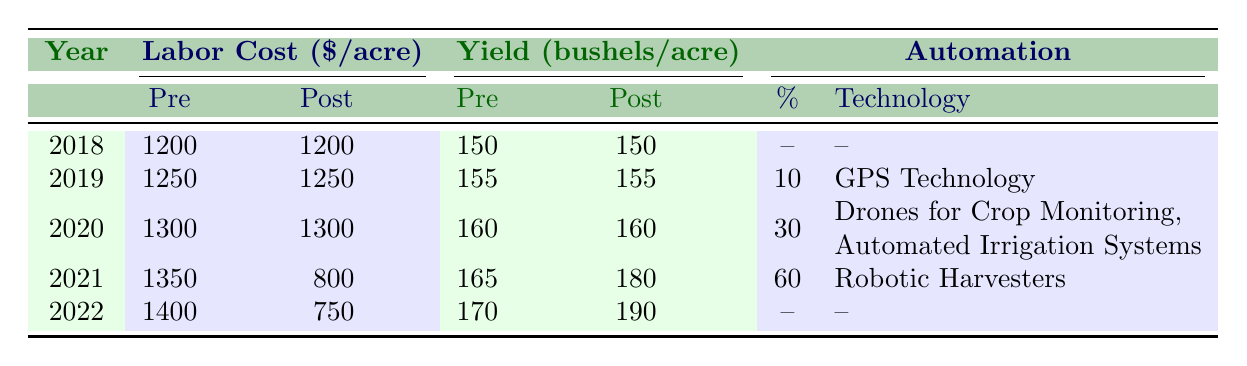What was the post-automation labor cost per acre in 2021? In the year 2021, the post-automation labor cost per acre is given directly in the table, which shows it as 800.
Answer: 800 What was the average yield per acre across the years before automation? To find the average yield before automation, we sum the pre-automation yield values: (150 + 155 + 160 + 165 + 170) = 800. Then, we divide the total by 5 (the number of years), which gives us an average of 800/5 = 160.
Answer: 160 Is the labor cost per acre lower after automation in 2022 compared to 2021? In 2022, the post-automation labor cost is 750, and in 2021 it is 800. Since 750 is less than 800, the statement is true.
Answer: Yes What was the percentage of automation adoption in 2020? Looking at the automation adoption section of the table, the adoption percentage for the year 2020 is specifically listed as 30.
Answer: 30 What is the total yield increase from pre-automation in 2021 to post-automation in 2022? To calculate the yield increase, we take the post-automation yield in 2022 (190) and subtract the pre-automation yield in 2021 (165). This results in an increase of 190 - 165 = 25 bushels per acre.
Answer: 25 Was GPS Technology the only technology adopted before 2021? The table indicates that in 2019, only GPS Technology was mentioned, and in 2020, two new technologies were adopted. Therefore, it confirms that GPS Technology was the only technology adopted before 2021.
Answer: Yes By how much did the post-automation yield per acre increase from 2021 to 2022? The post-automation yield per acre in 2022 was 190, and in 2021, it was 180. The difference is 190 - 180 = 10 bushels per acre.
Answer: 10 What is the trend in post-automation labor costs from 2019 to 2022? Analyzing the post-automation labor costs: in 2019 it was 1250, in 2020 it remained 1300, then dropped to 800 in 2021, and further decreased to 750 in 2022. This indicates a downward trend over the years.
Answer: Downward trend What were the technologies adopted in 2020? In 2020, two technologies were introduced: Drones for Crop Monitoring and Automated Irrigation Systems, as listed in the table under the corresponding year.
Answer: Drones for Crop Monitoring, Automated Irrigation Systems 